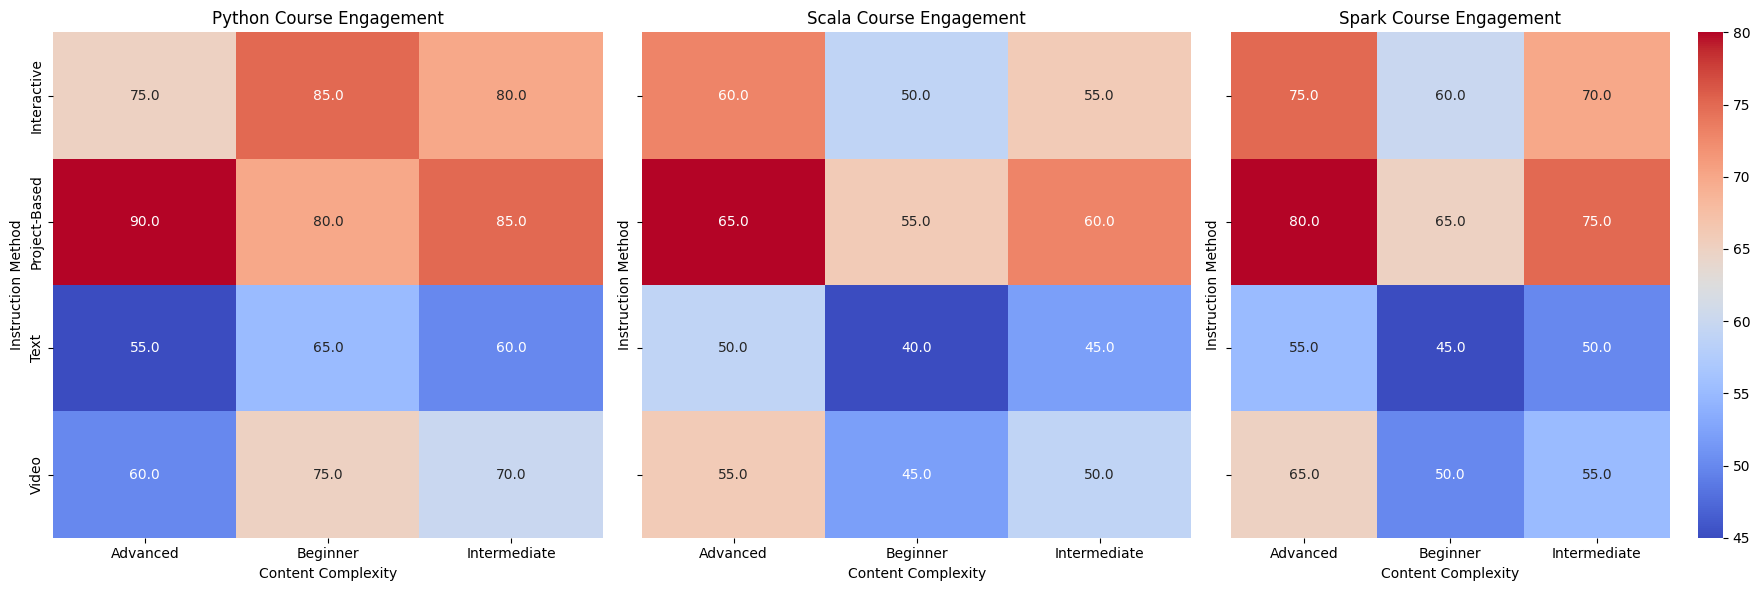Which instruction method has the highest user engagement for beginner-level Python courses? Look at the "User Engagement (Python)" heatmap and identify the cell in the "Beginner" row with the highest value. The "Interactive" instruction method has the highest engagement at 85.
Answer: Interactive Which instruction method demonstrates the greatest user engagement difference between intermediate-level Spark and Scala courses? Calculate the differences in user engagement for intermediate-level instruction methods between Spark and Scala. For "Video" (55 - 50 = 5), "Interactive" (70 - 55 = 15), "Text" (50 - 45 = 5), and "Project-Based" (75 - 60 = 15), the greatest difference is 15 for both "Interactive" and "Project-Based".
Answer: Interactive and Project-Based Which content complexity level shows the most consistent user engagement for Spark courses across different instruction methods? Examine the user engagement values for Spark courses at each content complexity level. For "Beginner," values are 50, 60, 45, 65. For "Intermediate," values are 55, 70, 50, 75. For "Advanced," values are 65, 75, 55, 80. "Advanced" has the least range (max - min: 80 - 55 = 25).
Answer: Advanced Compare the average user engagement of intermediate-level courses for Python and Scala using all instruction methods. Calculate the average for "Intermediate" in both Python and Scala heatmaps. Python: (70 + 80 + 60 + 85) / 4 = 73.75. Scala: (50 + 55 + 45 + 60) / 4 = 52.5. Compare the two averages.
Answer: Python's average is higher What is the difference in user engagement between video-based advanced Python and Spark courses? Subtract the user engagement value for "Video" advanced-level Spark (65) from Python (60). The difference is 60 - 65 = -5.
Answer: -5 Which beginner-level instruction method has the largest increase in user engagement for Spark compared to Scala? For "Beginner" level, compare Spark and Scala for each instruction method: "Video" (50 - 45 = 5), "Interactive" (60 - 50 = 10), "Text" (45 - 40 = 5), "Project-Based" (65 - 55 = 10). The largest increase is 10 in both "Interactive" and "Project-Based".
Answer: Interactive and Project-Based How does the user engagement of interactive advanced-level Scala courses compare to advanced-level text-based Scala courses? Find the values: Interactive advanced Scala (60) and Text advanced Scala (50). Compare 60 and 50.
Answer: Interactive is higher by 10 Which instruction method has the lowest engagement for intermediate-level Python courses? Identify the lowest value in the "Intermediate" row of "User Engagement (Python)" heatmap. It's 60 for "Text".
Answer: Text 